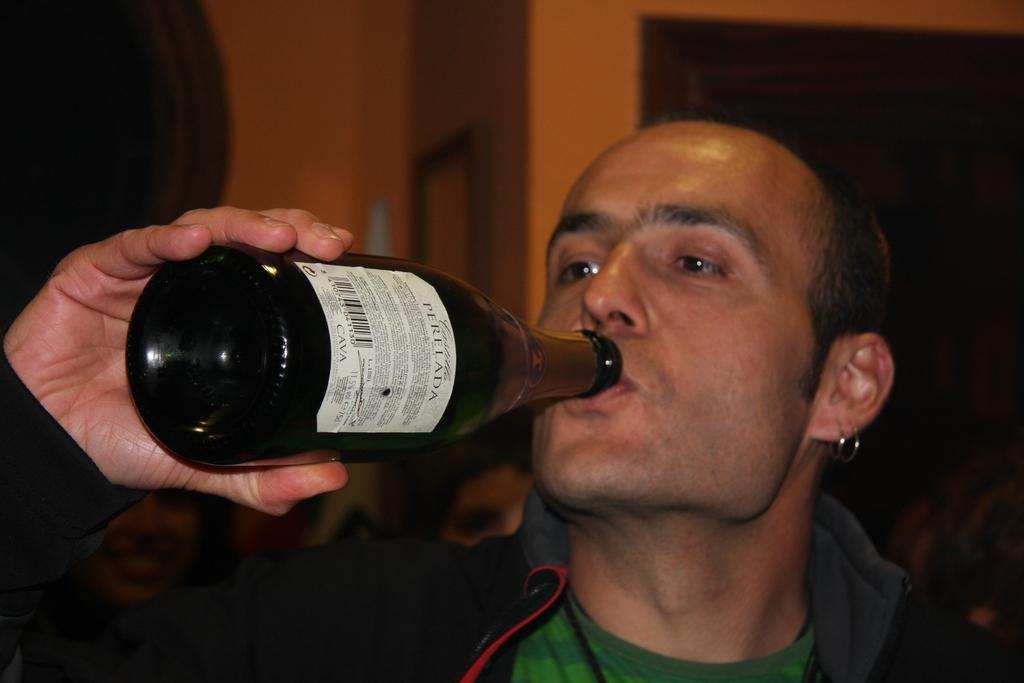What is the main subject of the image? There is a person in the image. What is the person holding in his hand? The person is holding a wine bottle in his hand. How old is the baby in the image? There is no baby present in the image. What type of watch is the governor wearing in the image? There is no watch or governor present in the image. 